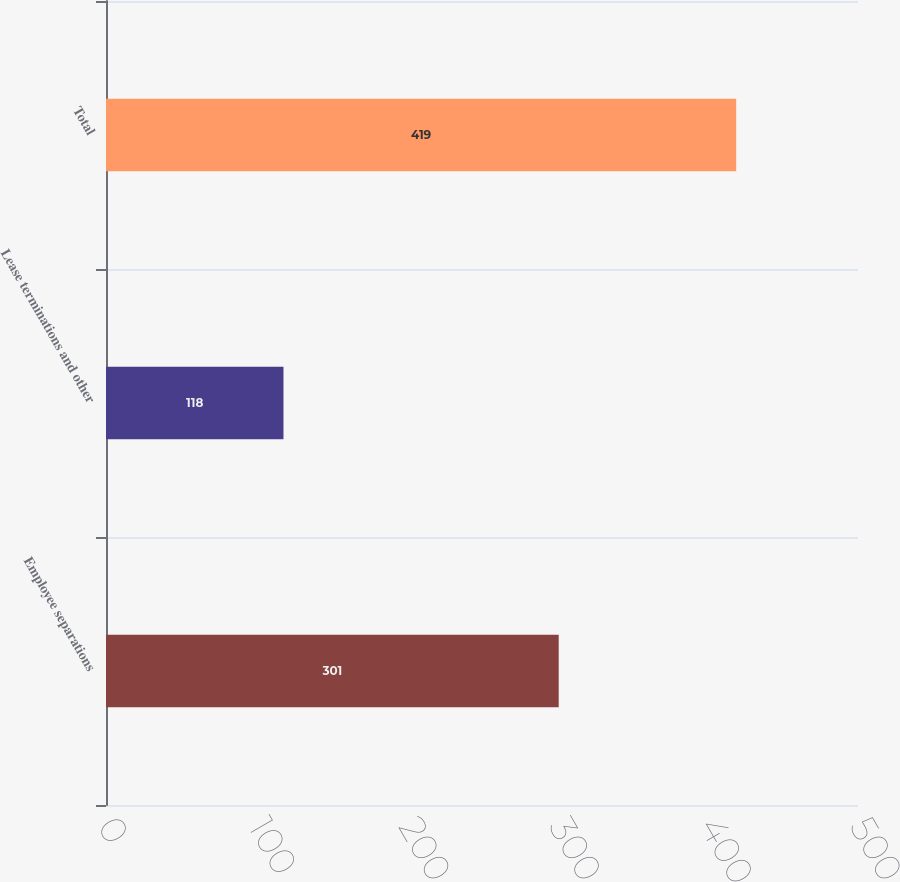Convert chart. <chart><loc_0><loc_0><loc_500><loc_500><bar_chart><fcel>Employee separations<fcel>Lease terminations and other<fcel>Total<nl><fcel>301<fcel>118<fcel>419<nl></chart> 